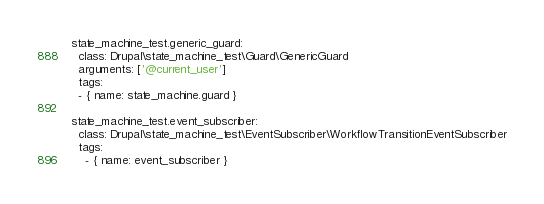Convert code to text. <code><loc_0><loc_0><loc_500><loc_500><_YAML_>  state_machine_test.generic_guard:
    class: Drupal\state_machine_test\Guard\GenericGuard
    arguments: ['@current_user']
    tags:
    - { name: state_machine.guard }

  state_machine_test.event_subscriber:
    class: Drupal\state_machine_test\EventSubscriber\WorkflowTransitionEventSubscriber
    tags:
      - { name: event_subscriber }
</code> 